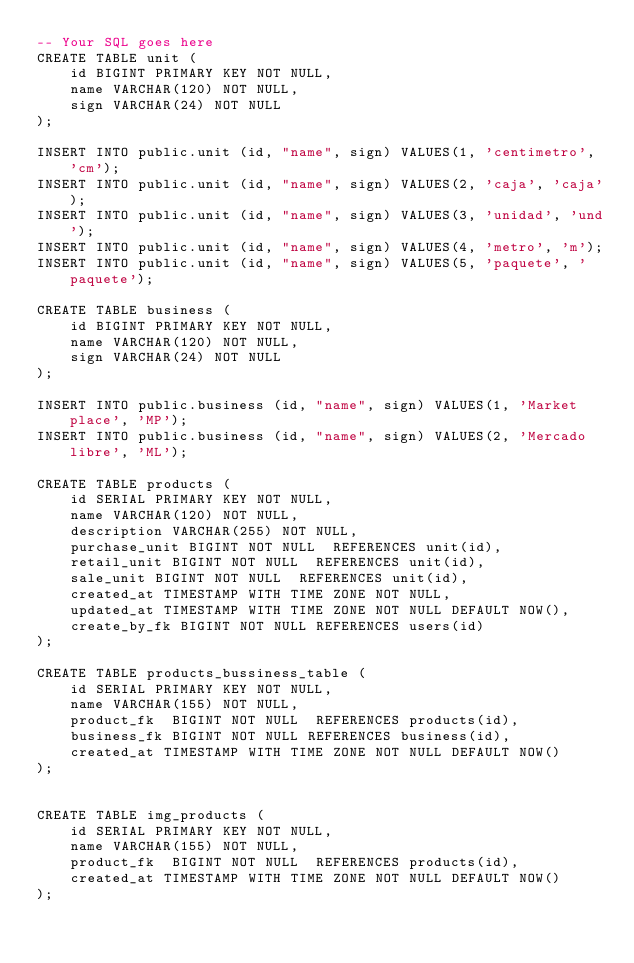Convert code to text. <code><loc_0><loc_0><loc_500><loc_500><_SQL_>-- Your SQL goes here
CREATE TABLE unit (
    id BIGINT PRIMARY KEY NOT NULL,
    name VARCHAR(120) NOT NULL,
    sign VARCHAR(24) NOT NULL
);

INSERT INTO public.unit (id, "name", sign) VALUES(1, 'centimetro', 'cm');
INSERT INTO public.unit (id, "name", sign) VALUES(2, 'caja', 'caja');
INSERT INTO public.unit (id, "name", sign) VALUES(3, 'unidad', 'und');
INSERT INTO public.unit (id, "name", sign) VALUES(4, 'metro', 'm');
INSERT INTO public.unit (id, "name", sign) VALUES(5, 'paquete', 'paquete');

CREATE TABLE business (
    id BIGINT PRIMARY KEY NOT NULL,
    name VARCHAR(120) NOT NULL,
    sign VARCHAR(24) NOT NULL
);

INSERT INTO public.business (id, "name", sign) VALUES(1, 'Market place', 'MP');
INSERT INTO public.business (id, "name", sign) VALUES(2, 'Mercado libre', 'ML');

CREATE TABLE products (
    id SERIAL PRIMARY KEY NOT NULL,
    name VARCHAR(120) NOT NULL,
    description VARCHAR(255) NOT NULL,
    purchase_unit BIGINT NOT NULL  REFERENCES unit(id),
    retail_unit BIGINT NOT NULL  REFERENCES unit(id),
    sale_unit BIGINT NOT NULL  REFERENCES unit(id),
    created_at TIMESTAMP WITH TIME ZONE NOT NULL,
    updated_at TIMESTAMP WITH TIME ZONE NOT NULL DEFAULT NOW(),
    create_by_fk BIGINT NOT NULL REFERENCES users(id)
);

CREATE TABLE products_bussiness_table (
    id SERIAL PRIMARY KEY NOT NULL,
    name VARCHAR(155) NOT NULL,
    product_fk  BIGINT NOT NULL  REFERENCES products(id),
    business_fk BIGINT NOT NULL REFERENCES business(id),
    created_at TIMESTAMP WITH TIME ZONE NOT NULL DEFAULT NOW()
);


CREATE TABLE img_products (
    id SERIAL PRIMARY KEY NOT NULL,
    name VARCHAR(155) NOT NULL,
    product_fk  BIGINT NOT NULL  REFERENCES products(id),
    created_at TIMESTAMP WITH TIME ZONE NOT NULL DEFAULT NOW()
);
</code> 